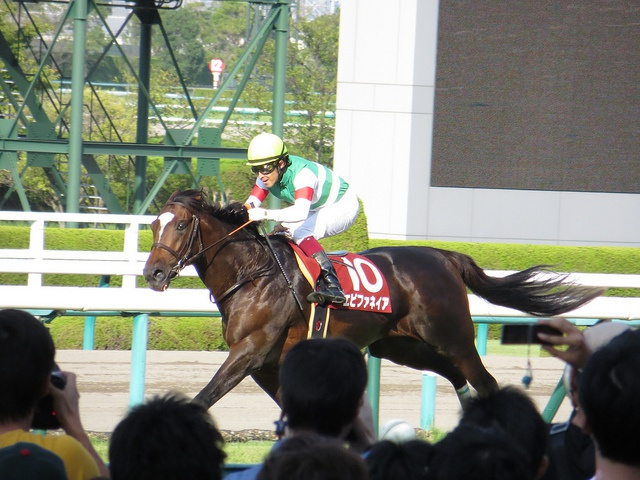Describe the objects in this image and their specific colors. I can see horse in gray, black, and maroon tones, people in gray, black, and darkgray tones, people in gray, black, and olive tones, people in gray, white, turquoise, and black tones, and people in gray, black, darkgray, and darkgreen tones in this image. 